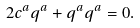Convert formula to latex. <formula><loc_0><loc_0><loc_500><loc_500>2 c ^ { a } q ^ { a } + q ^ { a } q ^ { a } = 0 .</formula> 